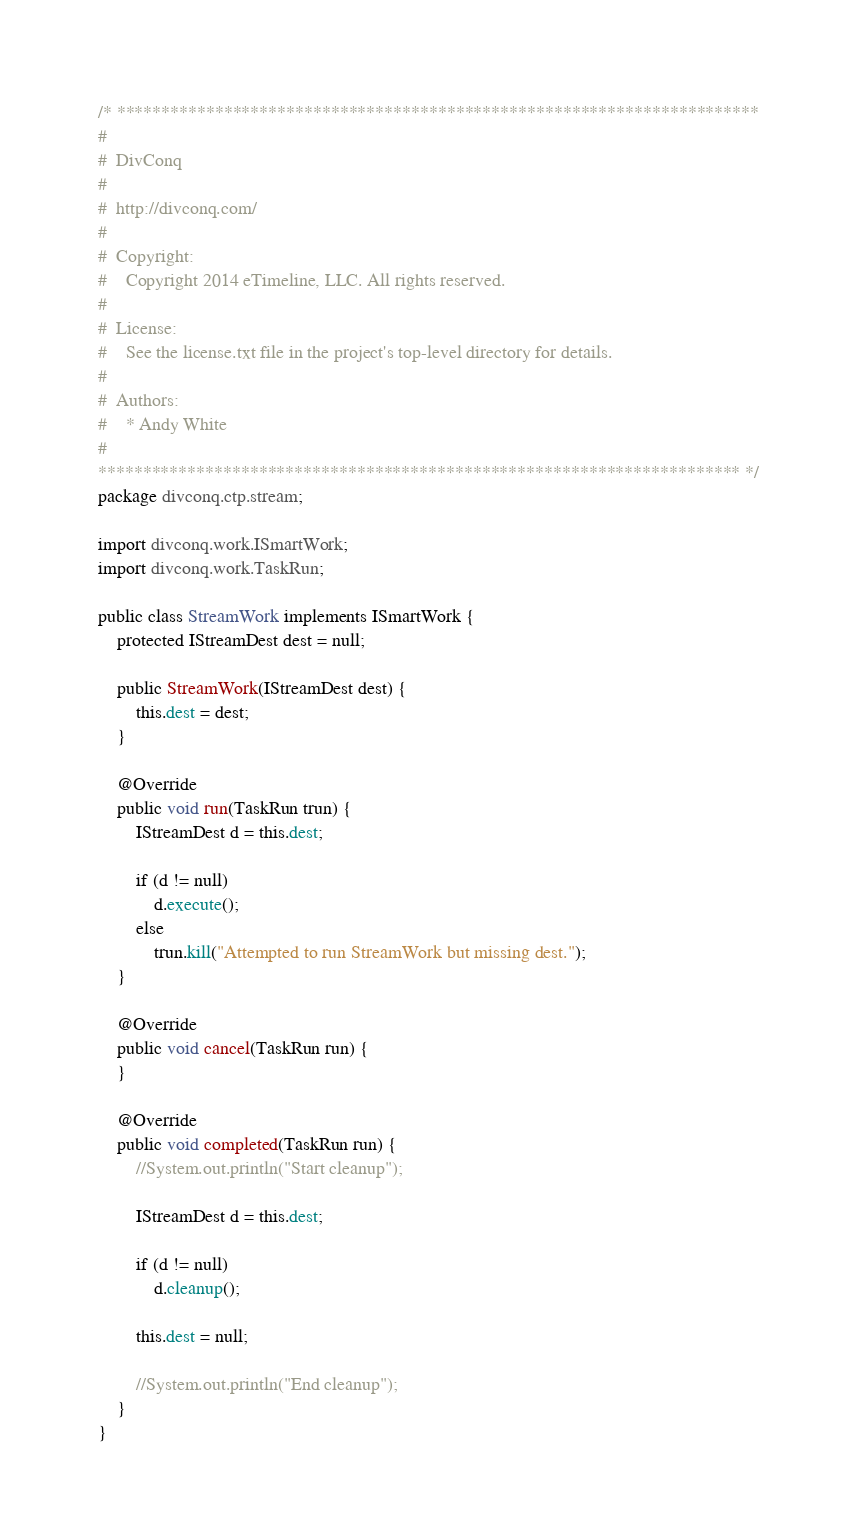<code> <loc_0><loc_0><loc_500><loc_500><_Java_>/* ************************************************************************
#
#  DivConq
#
#  http://divconq.com/
#
#  Copyright:
#    Copyright 2014 eTimeline, LLC. All rights reserved.
#
#  License:
#    See the license.txt file in the project's top-level directory for details.
#
#  Authors:
#    * Andy White
#
************************************************************************ */
package divconq.ctp.stream;

import divconq.work.ISmartWork;
import divconq.work.TaskRun;

public class StreamWork implements ISmartWork {
	protected IStreamDest dest = null;
	
	public StreamWork(IStreamDest dest) {
		this.dest = dest;
	}

	@Override
	public void run(TaskRun trun) {
		IStreamDest d = this.dest;
		
		if (d != null)
			d.execute();
		else 
			trun.kill("Attempted to run StreamWork but missing dest.");
	}

	@Override
	public void cancel(TaskRun run) {
	}

	@Override
	public void completed(TaskRun run) {
		//System.out.println("Start cleanup");
		
		IStreamDest d = this.dest;
		
		if (d != null)
			d.cleanup();
		
		this.dest = null;
		
		//System.out.println("End cleanup");
	}
}
</code> 